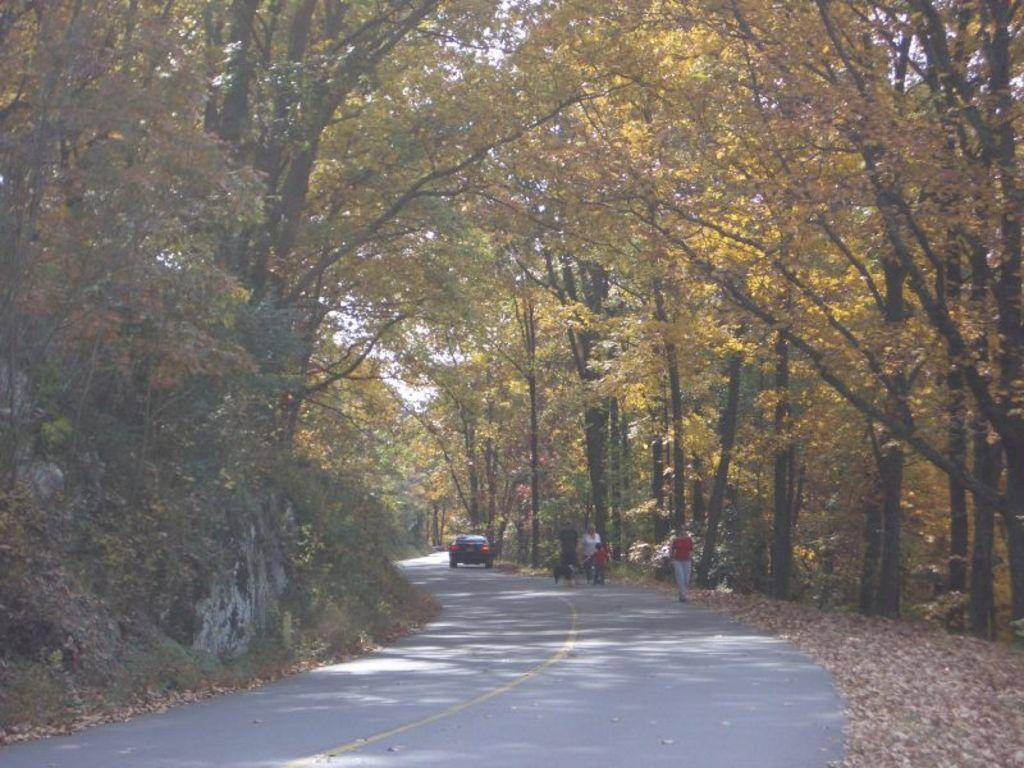What are the people in the image doing? The people in the image are walking. What animal is present in the image? There is a dog in the image. What type of transportation can be seen on the road in the image? There is a vehicle on the road in the image. What can be seen at the top of the image? Trees are visible at the top of the image. What type of growth is the lawyer experiencing in the image? There is no lawyer present in the image, and therefore no growth can be observed. 